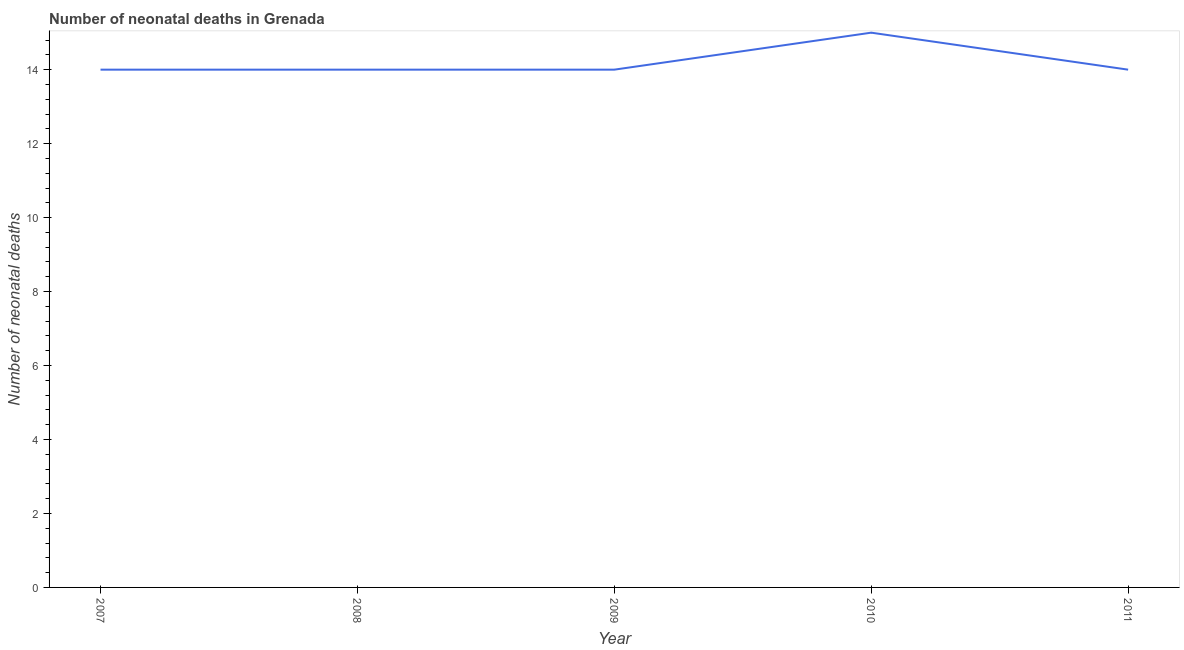What is the number of neonatal deaths in 2009?
Provide a succinct answer. 14. Across all years, what is the maximum number of neonatal deaths?
Give a very brief answer. 15. Across all years, what is the minimum number of neonatal deaths?
Your answer should be very brief. 14. In which year was the number of neonatal deaths minimum?
Keep it short and to the point. 2007. What is the sum of the number of neonatal deaths?
Make the answer very short. 71. What is the difference between the number of neonatal deaths in 2010 and 2011?
Ensure brevity in your answer.  1. What is the average number of neonatal deaths per year?
Ensure brevity in your answer.  14.2. In how many years, is the number of neonatal deaths greater than 8.8 ?
Offer a very short reply. 5. Is the number of neonatal deaths in 2007 less than that in 2010?
Your response must be concise. Yes. Is the difference between the number of neonatal deaths in 2007 and 2008 greater than the difference between any two years?
Ensure brevity in your answer.  No. What is the difference between the highest and the second highest number of neonatal deaths?
Your answer should be very brief. 1. What is the difference between the highest and the lowest number of neonatal deaths?
Keep it short and to the point. 1. In how many years, is the number of neonatal deaths greater than the average number of neonatal deaths taken over all years?
Provide a short and direct response. 1. How many lines are there?
Give a very brief answer. 1. How many years are there in the graph?
Give a very brief answer. 5. Does the graph contain any zero values?
Offer a terse response. No. What is the title of the graph?
Your answer should be very brief. Number of neonatal deaths in Grenada. What is the label or title of the Y-axis?
Offer a terse response. Number of neonatal deaths. What is the Number of neonatal deaths of 2008?
Offer a very short reply. 14. What is the difference between the Number of neonatal deaths in 2007 and 2008?
Your answer should be compact. 0. What is the difference between the Number of neonatal deaths in 2007 and 2010?
Your answer should be compact. -1. What is the difference between the Number of neonatal deaths in 2008 and 2009?
Offer a terse response. 0. What is the difference between the Number of neonatal deaths in 2009 and 2010?
Your response must be concise. -1. What is the difference between the Number of neonatal deaths in 2009 and 2011?
Make the answer very short. 0. What is the difference between the Number of neonatal deaths in 2010 and 2011?
Offer a terse response. 1. What is the ratio of the Number of neonatal deaths in 2007 to that in 2008?
Offer a terse response. 1. What is the ratio of the Number of neonatal deaths in 2007 to that in 2009?
Make the answer very short. 1. What is the ratio of the Number of neonatal deaths in 2007 to that in 2010?
Offer a terse response. 0.93. What is the ratio of the Number of neonatal deaths in 2008 to that in 2009?
Offer a very short reply. 1. What is the ratio of the Number of neonatal deaths in 2008 to that in 2010?
Your response must be concise. 0.93. What is the ratio of the Number of neonatal deaths in 2008 to that in 2011?
Make the answer very short. 1. What is the ratio of the Number of neonatal deaths in 2009 to that in 2010?
Ensure brevity in your answer.  0.93. What is the ratio of the Number of neonatal deaths in 2009 to that in 2011?
Make the answer very short. 1. What is the ratio of the Number of neonatal deaths in 2010 to that in 2011?
Your answer should be very brief. 1.07. 